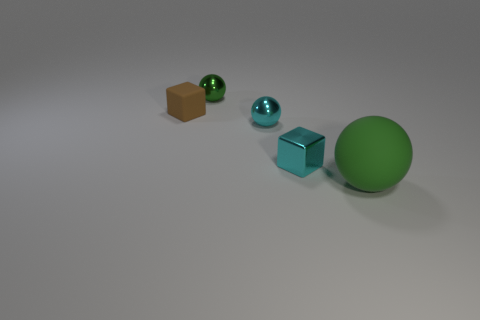Subtract all spheres. How many objects are left? 2 Add 3 large red matte cylinders. How many objects exist? 8 Add 2 big matte spheres. How many big matte spheres are left? 3 Add 1 tiny cyan blocks. How many tiny cyan blocks exist? 2 Subtract 0 cyan cylinders. How many objects are left? 5 Subtract all big red matte blocks. Subtract all brown rubber objects. How many objects are left? 4 